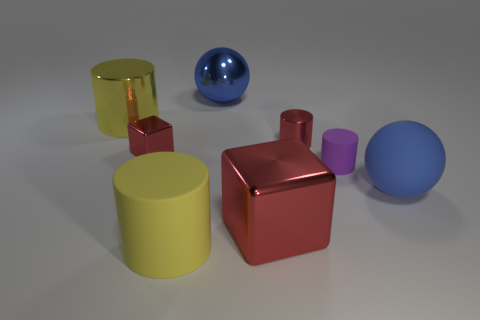Subtract all purple matte cylinders. How many cylinders are left? 3 Subtract 2 cylinders. How many cylinders are left? 2 Add 1 big cyan shiny balls. How many objects exist? 9 Subtract all red cylinders. How many cylinders are left? 3 Subtract all spheres. How many objects are left? 6 Subtract all cyan cylinders. Subtract all red balls. How many cylinders are left? 4 Subtract 0 blue cylinders. How many objects are left? 8 Subtract all small cubes. Subtract all small red metallic blocks. How many objects are left? 6 Add 2 large shiny balls. How many large shiny balls are left? 3 Add 4 small gray spheres. How many small gray spheres exist? 4 